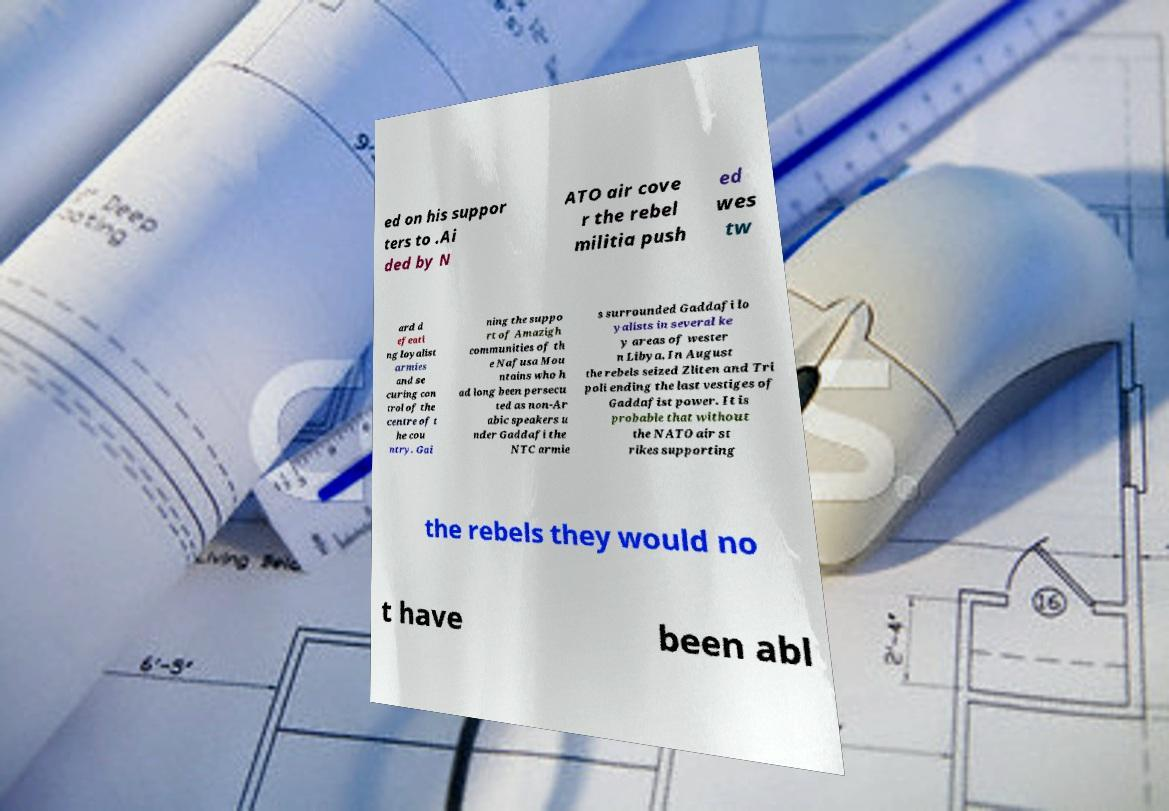I need the written content from this picture converted into text. Can you do that? ed on his suppor ters to .Ai ded by N ATO air cove r the rebel militia push ed wes tw ard d efeati ng loyalist armies and se curing con trol of the centre of t he cou ntry. Gai ning the suppo rt of Amazigh communities of th e Nafusa Mou ntains who h ad long been persecu ted as non-Ar abic speakers u nder Gaddafi the NTC armie s surrounded Gaddafi lo yalists in several ke y areas of wester n Libya. In August the rebels seized Zliten and Tri poli ending the last vestiges of Gaddafist power. It is probable that without the NATO air st rikes supporting the rebels they would no t have been abl 